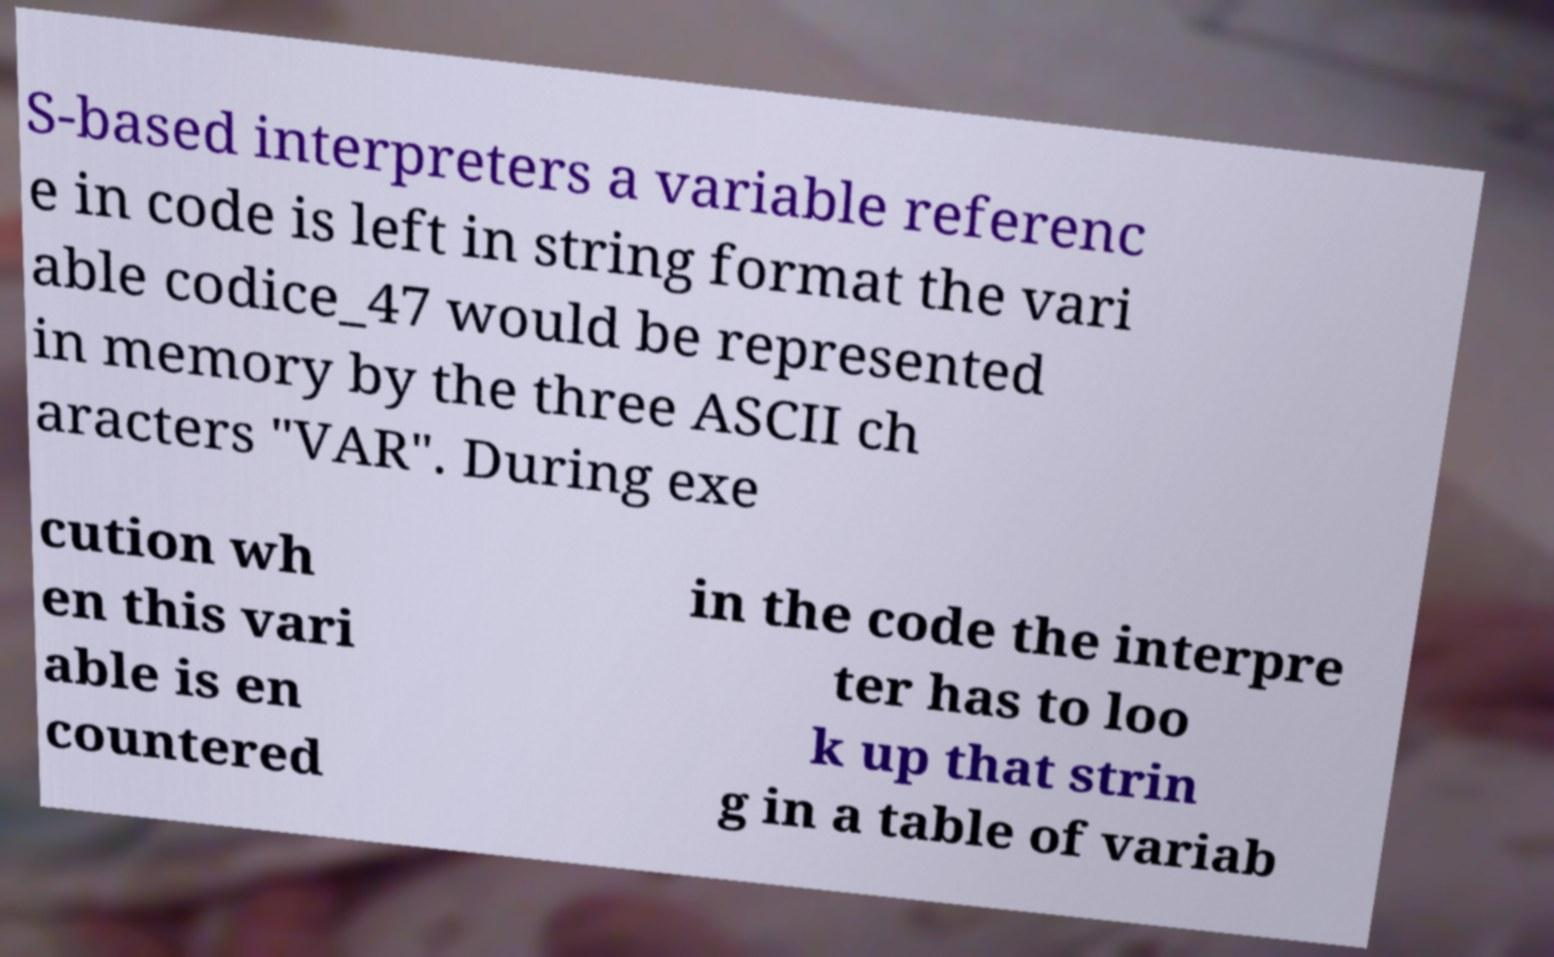I need the written content from this picture converted into text. Can you do that? S-based interpreters a variable referenc e in code is left in string format the vari able codice_47 would be represented in memory by the three ASCII ch aracters "VAR". During exe cution wh en this vari able is en countered in the code the interpre ter has to loo k up that strin g in a table of variab 